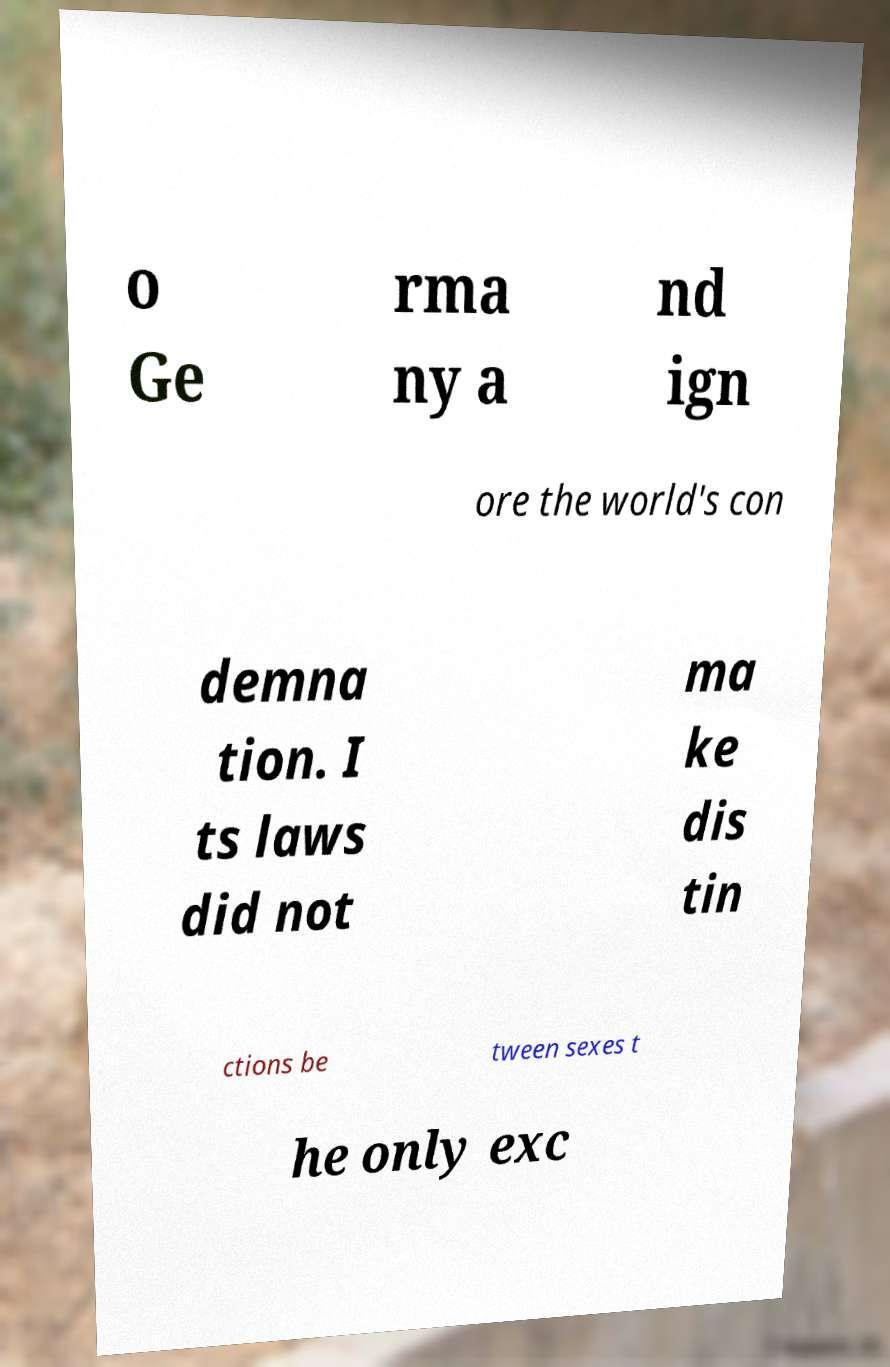There's text embedded in this image that I need extracted. Can you transcribe it verbatim? o Ge rma ny a nd ign ore the world's con demna tion. I ts laws did not ma ke dis tin ctions be tween sexes t he only exc 